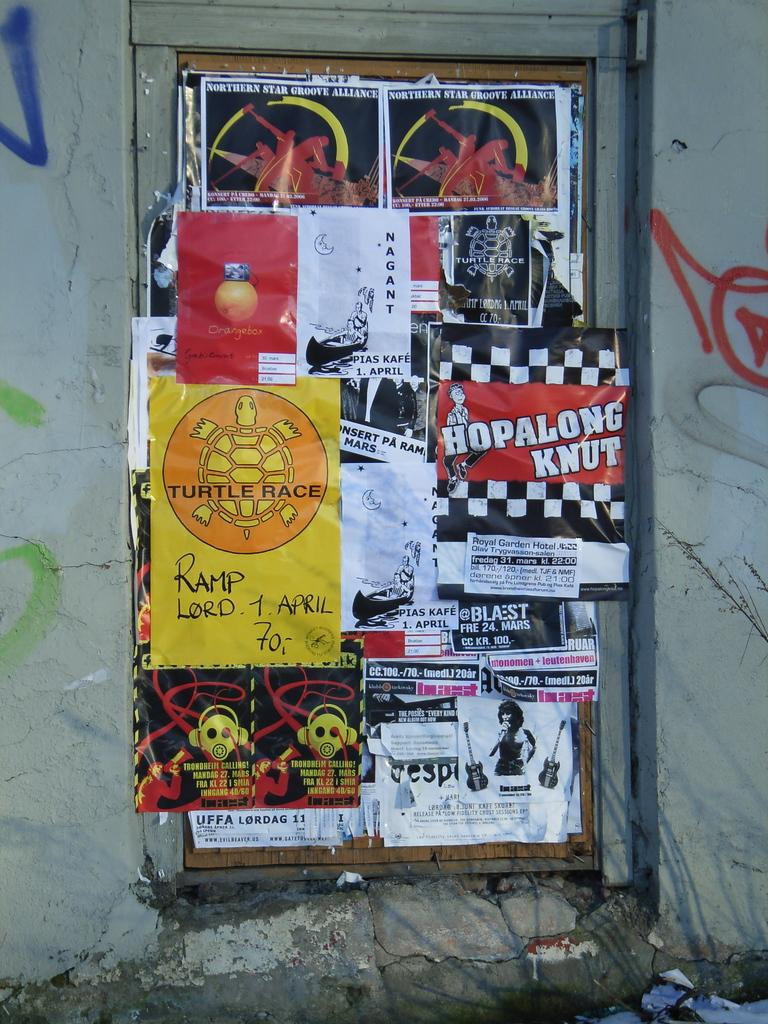<image>
Describe the image concisely. wall plaster with posters for such things as northern star groove alliance, hopalong knut, and turtle race 